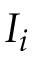Convert formula to latex. <formula><loc_0><loc_0><loc_500><loc_500>I _ { i }</formula> 